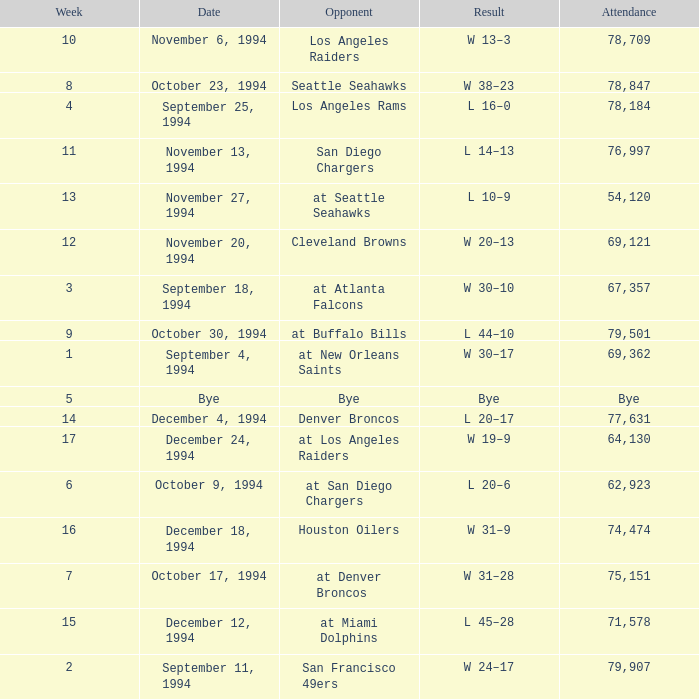What was the score of the Chiefs November 27, 1994 game? L 10–9. 